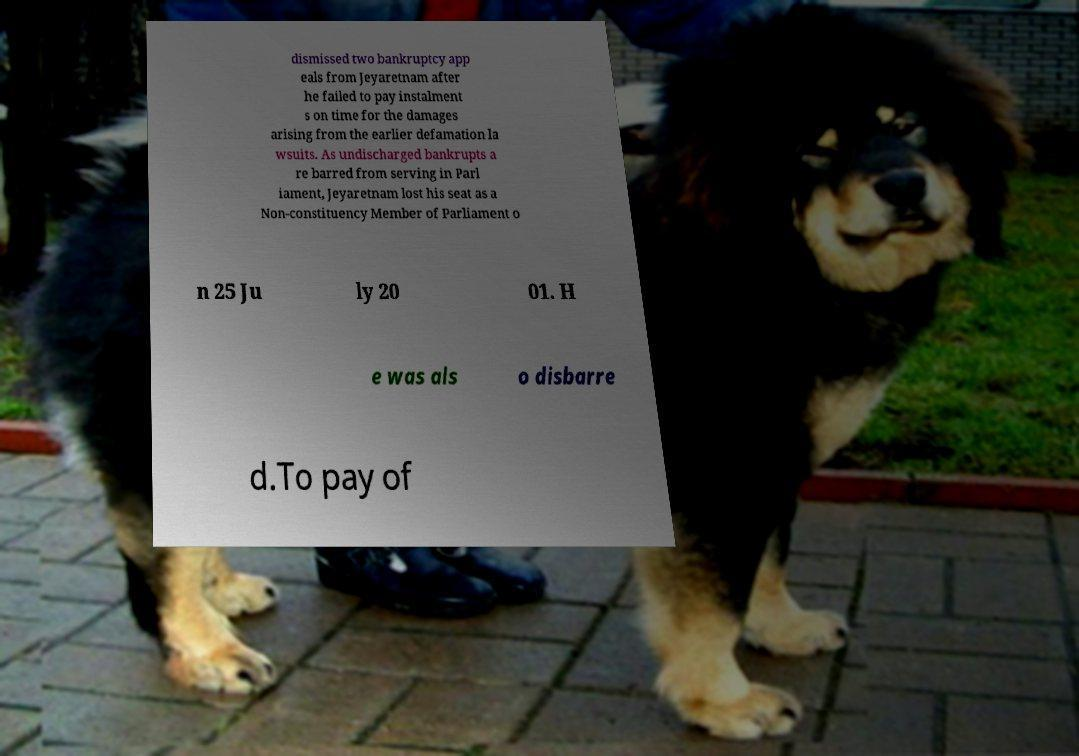Please read and relay the text visible in this image. What does it say? dismissed two bankruptcy app eals from Jeyaretnam after he failed to pay instalment s on time for the damages arising from the earlier defamation la wsuits. As undischarged bankrupts a re barred from serving in Parl iament, Jeyaretnam lost his seat as a Non-constituency Member of Parliament o n 25 Ju ly 20 01. H e was als o disbarre d.To pay of 